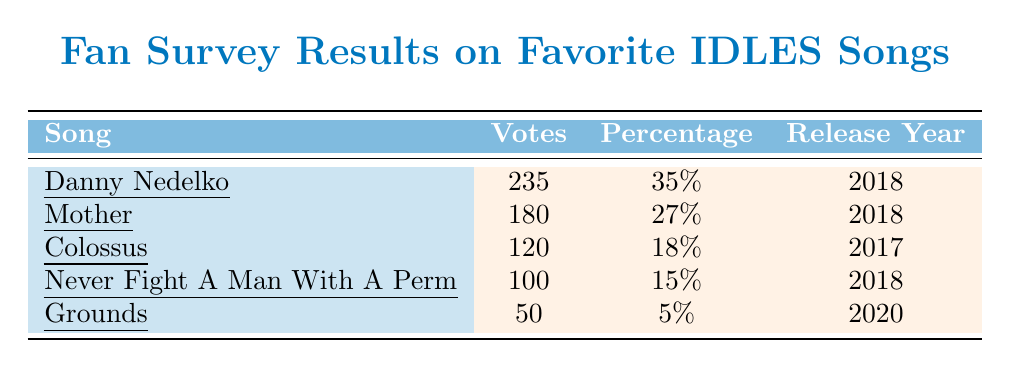What song received the highest number of votes? The table lists the song "Danny Nedelko" at the top with 235 votes, which is the highest vote count among all songs.
Answer: Danny Nedelko What percentage of votes did "Mother" receive? In the table, "Mother" shows a percentage of 27%, which is explicitly mentioned in the second row.
Answer: 27% How many votes did "Grounds" receive? The table shows "Grounds" with 50 votes in the last row, providing the specific count for that song.
Answer: 50 votes Which song has the lowest percentage of votes? By looking at the percentages listed, "Grounds" has a percentage of 5%, making it the lowest among the songs.
Answer: Grounds What is the difference in votes between "Colossus" and "Never Fight A Man With A Perm"? "Colossus" received 120 votes while "Never Fight A Man With A Perm" received 100 votes. The difference is calculated as 120 - 100 = 20.
Answer: 20 votes What is the total number of votes for all songs combined? Adding together the votes: 235 (Danny Nedelko) + 180 (Mother) + 120 (Colossus) + 100 (Never Fight A Man With A Perm) + 50 (Grounds) equals a total of 685 votes combined.
Answer: 685 votes Which song released in 2018 has the fewest votes? In the 2018 release category, "Never Fight A Man With A Perm" has 100 votes and "Mother" has 180 votes. Therefore, "Never Fight A Man With A Perm" has the fewest votes among 2018 songs.
Answer: Never Fight A Man With A Perm Is "Colossus" the only song released in 2017? The table indicates "Colossus" was released in 2017 and lists other songs, but it doesn't show any other songs released in that year. Therefore, the statement is true.
Answer: Yes What is the average percentage of votes for all songs listed? To find the average percentage, sum all percentages (35 + 27 + 18 + 15 + 5 = 100) and divide by the number of songs (5), leading to an average of 100 / 5 = 20%.
Answer: 20% How many comments were made about the song "Danny Nedelko"? The table provides two comments listed under "Danny Nedelko", showing that there were two comments for that song.
Answer: 2 comments 